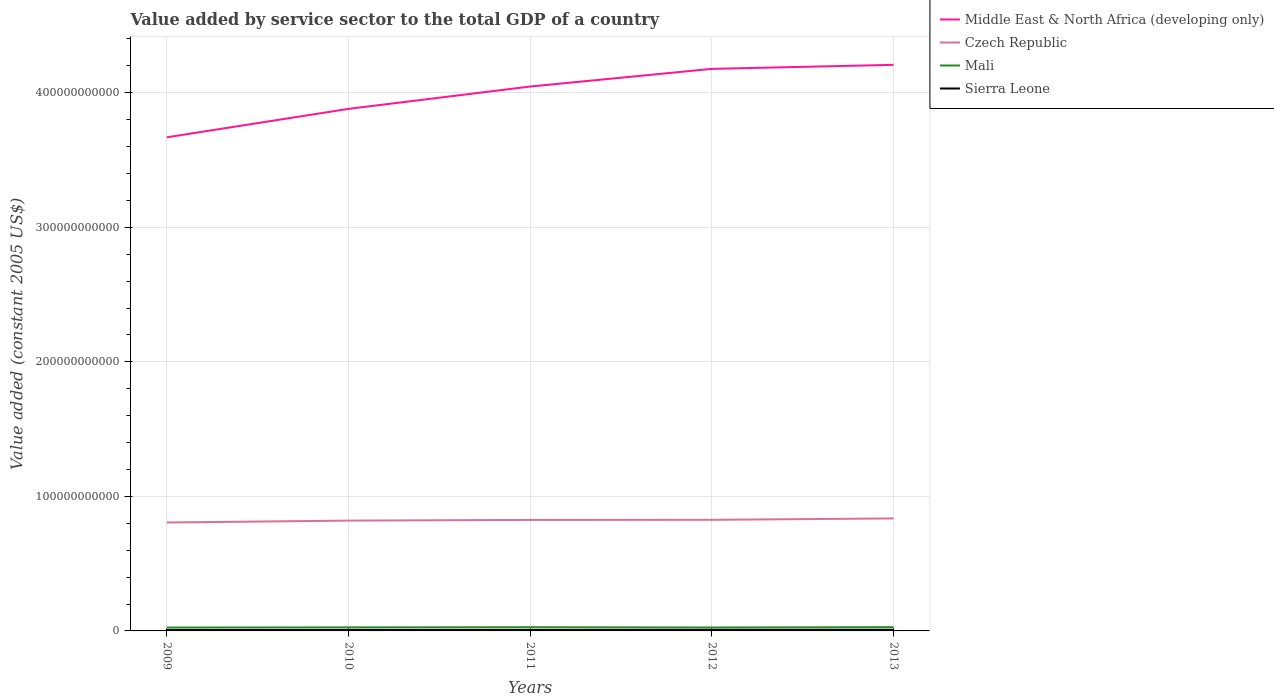How many different coloured lines are there?
Ensure brevity in your answer.  4. Does the line corresponding to Sierra Leone intersect with the line corresponding to Middle East & North Africa (developing only)?
Give a very brief answer. No. Is the number of lines equal to the number of legend labels?
Provide a succinct answer. Yes. Across all years, what is the maximum value added by service sector in Czech Republic?
Make the answer very short. 8.06e+1. In which year was the value added by service sector in Middle East & North Africa (developing only) maximum?
Give a very brief answer. 2009. What is the total value added by service sector in Sierra Leone in the graph?
Provide a short and direct response. -1.74e+07. What is the difference between the highest and the second highest value added by service sector in Czech Republic?
Your answer should be compact. 3.04e+09. Is the value added by service sector in Sierra Leone strictly greater than the value added by service sector in Czech Republic over the years?
Your answer should be compact. Yes. What is the difference between two consecutive major ticks on the Y-axis?
Offer a very short reply. 1.00e+11. Are the values on the major ticks of Y-axis written in scientific E-notation?
Make the answer very short. No. Does the graph contain any zero values?
Provide a succinct answer. No. Where does the legend appear in the graph?
Provide a succinct answer. Top right. How are the legend labels stacked?
Give a very brief answer. Vertical. What is the title of the graph?
Your response must be concise. Value added by service sector to the total GDP of a country. What is the label or title of the Y-axis?
Provide a short and direct response. Value added (constant 2005 US$). What is the Value added (constant 2005 US$) in Middle East & North Africa (developing only) in 2009?
Offer a terse response. 3.67e+11. What is the Value added (constant 2005 US$) of Czech Republic in 2009?
Keep it short and to the point. 8.06e+1. What is the Value added (constant 2005 US$) of Mali in 2009?
Offer a very short reply. 2.51e+09. What is the Value added (constant 2005 US$) of Sierra Leone in 2009?
Offer a terse response. 6.68e+08. What is the Value added (constant 2005 US$) in Middle East & North Africa (developing only) in 2010?
Keep it short and to the point. 3.88e+11. What is the Value added (constant 2005 US$) of Czech Republic in 2010?
Provide a short and direct response. 8.20e+1. What is the Value added (constant 2005 US$) of Mali in 2010?
Your answer should be very brief. 2.63e+09. What is the Value added (constant 2005 US$) of Sierra Leone in 2010?
Ensure brevity in your answer.  7.14e+08. What is the Value added (constant 2005 US$) in Middle East & North Africa (developing only) in 2011?
Provide a short and direct response. 4.05e+11. What is the Value added (constant 2005 US$) of Czech Republic in 2011?
Keep it short and to the point. 8.25e+1. What is the Value added (constant 2005 US$) in Mali in 2011?
Your answer should be compact. 2.73e+09. What is the Value added (constant 2005 US$) of Sierra Leone in 2011?
Make the answer very short. 7.31e+08. What is the Value added (constant 2005 US$) in Middle East & North Africa (developing only) in 2012?
Make the answer very short. 4.18e+11. What is the Value added (constant 2005 US$) in Czech Republic in 2012?
Provide a short and direct response. 8.26e+1. What is the Value added (constant 2005 US$) in Mali in 2012?
Offer a terse response. 2.54e+09. What is the Value added (constant 2005 US$) of Sierra Leone in 2012?
Your answer should be very brief. 7.75e+08. What is the Value added (constant 2005 US$) in Middle East & North Africa (developing only) in 2013?
Offer a terse response. 4.21e+11. What is the Value added (constant 2005 US$) in Czech Republic in 2013?
Provide a succinct answer. 8.36e+1. What is the Value added (constant 2005 US$) of Mali in 2013?
Offer a very short reply. 2.77e+09. What is the Value added (constant 2005 US$) in Sierra Leone in 2013?
Offer a terse response. 8.22e+08. Across all years, what is the maximum Value added (constant 2005 US$) in Middle East & North Africa (developing only)?
Make the answer very short. 4.21e+11. Across all years, what is the maximum Value added (constant 2005 US$) in Czech Republic?
Your answer should be very brief. 8.36e+1. Across all years, what is the maximum Value added (constant 2005 US$) of Mali?
Offer a very short reply. 2.77e+09. Across all years, what is the maximum Value added (constant 2005 US$) of Sierra Leone?
Offer a terse response. 8.22e+08. Across all years, what is the minimum Value added (constant 2005 US$) of Middle East & North Africa (developing only)?
Your response must be concise. 3.67e+11. Across all years, what is the minimum Value added (constant 2005 US$) in Czech Republic?
Your answer should be very brief. 8.06e+1. Across all years, what is the minimum Value added (constant 2005 US$) in Mali?
Provide a succinct answer. 2.51e+09. Across all years, what is the minimum Value added (constant 2005 US$) in Sierra Leone?
Your response must be concise. 6.68e+08. What is the total Value added (constant 2005 US$) in Middle East & North Africa (developing only) in the graph?
Provide a short and direct response. 2.00e+12. What is the total Value added (constant 2005 US$) in Czech Republic in the graph?
Provide a short and direct response. 4.11e+11. What is the total Value added (constant 2005 US$) in Mali in the graph?
Give a very brief answer. 1.32e+1. What is the total Value added (constant 2005 US$) of Sierra Leone in the graph?
Ensure brevity in your answer.  3.71e+09. What is the difference between the Value added (constant 2005 US$) of Middle East & North Africa (developing only) in 2009 and that in 2010?
Offer a very short reply. -2.12e+1. What is the difference between the Value added (constant 2005 US$) in Czech Republic in 2009 and that in 2010?
Your answer should be compact. -1.40e+09. What is the difference between the Value added (constant 2005 US$) of Mali in 2009 and that in 2010?
Make the answer very short. -1.14e+08. What is the difference between the Value added (constant 2005 US$) of Sierra Leone in 2009 and that in 2010?
Make the answer very short. -4.56e+07. What is the difference between the Value added (constant 2005 US$) in Middle East & North Africa (developing only) in 2009 and that in 2011?
Keep it short and to the point. -3.78e+1. What is the difference between the Value added (constant 2005 US$) in Czech Republic in 2009 and that in 2011?
Keep it short and to the point. -1.93e+09. What is the difference between the Value added (constant 2005 US$) of Mali in 2009 and that in 2011?
Make the answer very short. -2.14e+08. What is the difference between the Value added (constant 2005 US$) of Sierra Leone in 2009 and that in 2011?
Offer a very short reply. -6.30e+07. What is the difference between the Value added (constant 2005 US$) in Middle East & North Africa (developing only) in 2009 and that in 2012?
Keep it short and to the point. -5.09e+1. What is the difference between the Value added (constant 2005 US$) of Czech Republic in 2009 and that in 2012?
Your answer should be very brief. -2.00e+09. What is the difference between the Value added (constant 2005 US$) of Mali in 2009 and that in 2012?
Ensure brevity in your answer.  -3.21e+07. What is the difference between the Value added (constant 2005 US$) of Sierra Leone in 2009 and that in 2012?
Keep it short and to the point. -1.07e+08. What is the difference between the Value added (constant 2005 US$) of Middle East & North Africa (developing only) in 2009 and that in 2013?
Your answer should be compact. -5.39e+1. What is the difference between the Value added (constant 2005 US$) of Czech Republic in 2009 and that in 2013?
Make the answer very short. -3.04e+09. What is the difference between the Value added (constant 2005 US$) in Mali in 2009 and that in 2013?
Give a very brief answer. -2.59e+08. What is the difference between the Value added (constant 2005 US$) in Sierra Leone in 2009 and that in 2013?
Keep it short and to the point. -1.54e+08. What is the difference between the Value added (constant 2005 US$) of Middle East & North Africa (developing only) in 2010 and that in 2011?
Offer a terse response. -1.66e+1. What is the difference between the Value added (constant 2005 US$) of Czech Republic in 2010 and that in 2011?
Provide a short and direct response. -5.31e+08. What is the difference between the Value added (constant 2005 US$) in Mali in 2010 and that in 2011?
Your answer should be very brief. -1.00e+08. What is the difference between the Value added (constant 2005 US$) in Sierra Leone in 2010 and that in 2011?
Provide a succinct answer. -1.74e+07. What is the difference between the Value added (constant 2005 US$) in Middle East & North Africa (developing only) in 2010 and that in 2012?
Ensure brevity in your answer.  -2.97e+1. What is the difference between the Value added (constant 2005 US$) in Czech Republic in 2010 and that in 2012?
Offer a terse response. -5.99e+08. What is the difference between the Value added (constant 2005 US$) of Mali in 2010 and that in 2012?
Provide a short and direct response. 8.20e+07. What is the difference between the Value added (constant 2005 US$) of Sierra Leone in 2010 and that in 2012?
Your answer should be very brief. -6.15e+07. What is the difference between the Value added (constant 2005 US$) in Middle East & North Africa (developing only) in 2010 and that in 2013?
Provide a short and direct response. -3.27e+1. What is the difference between the Value added (constant 2005 US$) in Czech Republic in 2010 and that in 2013?
Your response must be concise. -1.63e+09. What is the difference between the Value added (constant 2005 US$) of Mali in 2010 and that in 2013?
Your response must be concise. -1.45e+08. What is the difference between the Value added (constant 2005 US$) in Sierra Leone in 2010 and that in 2013?
Ensure brevity in your answer.  -1.08e+08. What is the difference between the Value added (constant 2005 US$) in Middle East & North Africa (developing only) in 2011 and that in 2012?
Keep it short and to the point. -1.31e+1. What is the difference between the Value added (constant 2005 US$) in Czech Republic in 2011 and that in 2012?
Give a very brief answer. -6.85e+07. What is the difference between the Value added (constant 2005 US$) in Mali in 2011 and that in 2012?
Ensure brevity in your answer.  1.82e+08. What is the difference between the Value added (constant 2005 US$) in Sierra Leone in 2011 and that in 2012?
Provide a succinct answer. -4.41e+07. What is the difference between the Value added (constant 2005 US$) in Middle East & North Africa (developing only) in 2011 and that in 2013?
Offer a terse response. -1.61e+1. What is the difference between the Value added (constant 2005 US$) of Czech Republic in 2011 and that in 2013?
Your answer should be very brief. -1.10e+09. What is the difference between the Value added (constant 2005 US$) in Mali in 2011 and that in 2013?
Provide a short and direct response. -4.50e+07. What is the difference between the Value added (constant 2005 US$) of Sierra Leone in 2011 and that in 2013?
Your answer should be compact. -9.05e+07. What is the difference between the Value added (constant 2005 US$) in Middle East & North Africa (developing only) in 2012 and that in 2013?
Ensure brevity in your answer.  -2.99e+09. What is the difference between the Value added (constant 2005 US$) in Czech Republic in 2012 and that in 2013?
Make the answer very short. -1.04e+09. What is the difference between the Value added (constant 2005 US$) in Mali in 2012 and that in 2013?
Ensure brevity in your answer.  -2.27e+08. What is the difference between the Value added (constant 2005 US$) in Sierra Leone in 2012 and that in 2013?
Provide a short and direct response. -4.64e+07. What is the difference between the Value added (constant 2005 US$) of Middle East & North Africa (developing only) in 2009 and the Value added (constant 2005 US$) of Czech Republic in 2010?
Make the answer very short. 2.85e+11. What is the difference between the Value added (constant 2005 US$) of Middle East & North Africa (developing only) in 2009 and the Value added (constant 2005 US$) of Mali in 2010?
Your response must be concise. 3.64e+11. What is the difference between the Value added (constant 2005 US$) of Middle East & North Africa (developing only) in 2009 and the Value added (constant 2005 US$) of Sierra Leone in 2010?
Give a very brief answer. 3.66e+11. What is the difference between the Value added (constant 2005 US$) of Czech Republic in 2009 and the Value added (constant 2005 US$) of Mali in 2010?
Make the answer very short. 7.80e+1. What is the difference between the Value added (constant 2005 US$) of Czech Republic in 2009 and the Value added (constant 2005 US$) of Sierra Leone in 2010?
Offer a terse response. 7.99e+1. What is the difference between the Value added (constant 2005 US$) in Mali in 2009 and the Value added (constant 2005 US$) in Sierra Leone in 2010?
Your response must be concise. 1.80e+09. What is the difference between the Value added (constant 2005 US$) of Middle East & North Africa (developing only) in 2009 and the Value added (constant 2005 US$) of Czech Republic in 2011?
Keep it short and to the point. 2.84e+11. What is the difference between the Value added (constant 2005 US$) of Middle East & North Africa (developing only) in 2009 and the Value added (constant 2005 US$) of Mali in 2011?
Make the answer very short. 3.64e+11. What is the difference between the Value added (constant 2005 US$) in Middle East & North Africa (developing only) in 2009 and the Value added (constant 2005 US$) in Sierra Leone in 2011?
Give a very brief answer. 3.66e+11. What is the difference between the Value added (constant 2005 US$) in Czech Republic in 2009 and the Value added (constant 2005 US$) in Mali in 2011?
Your answer should be compact. 7.79e+1. What is the difference between the Value added (constant 2005 US$) of Czech Republic in 2009 and the Value added (constant 2005 US$) of Sierra Leone in 2011?
Your response must be concise. 7.99e+1. What is the difference between the Value added (constant 2005 US$) of Mali in 2009 and the Value added (constant 2005 US$) of Sierra Leone in 2011?
Offer a very short reply. 1.78e+09. What is the difference between the Value added (constant 2005 US$) in Middle East & North Africa (developing only) in 2009 and the Value added (constant 2005 US$) in Czech Republic in 2012?
Your answer should be very brief. 2.84e+11. What is the difference between the Value added (constant 2005 US$) of Middle East & North Africa (developing only) in 2009 and the Value added (constant 2005 US$) of Mali in 2012?
Provide a succinct answer. 3.64e+11. What is the difference between the Value added (constant 2005 US$) of Middle East & North Africa (developing only) in 2009 and the Value added (constant 2005 US$) of Sierra Leone in 2012?
Keep it short and to the point. 3.66e+11. What is the difference between the Value added (constant 2005 US$) of Czech Republic in 2009 and the Value added (constant 2005 US$) of Mali in 2012?
Provide a short and direct response. 7.80e+1. What is the difference between the Value added (constant 2005 US$) of Czech Republic in 2009 and the Value added (constant 2005 US$) of Sierra Leone in 2012?
Give a very brief answer. 7.98e+1. What is the difference between the Value added (constant 2005 US$) of Mali in 2009 and the Value added (constant 2005 US$) of Sierra Leone in 2012?
Keep it short and to the point. 1.74e+09. What is the difference between the Value added (constant 2005 US$) of Middle East & North Africa (developing only) in 2009 and the Value added (constant 2005 US$) of Czech Republic in 2013?
Provide a short and direct response. 2.83e+11. What is the difference between the Value added (constant 2005 US$) of Middle East & North Africa (developing only) in 2009 and the Value added (constant 2005 US$) of Mali in 2013?
Offer a very short reply. 3.64e+11. What is the difference between the Value added (constant 2005 US$) of Middle East & North Africa (developing only) in 2009 and the Value added (constant 2005 US$) of Sierra Leone in 2013?
Ensure brevity in your answer.  3.66e+11. What is the difference between the Value added (constant 2005 US$) of Czech Republic in 2009 and the Value added (constant 2005 US$) of Mali in 2013?
Your answer should be very brief. 7.78e+1. What is the difference between the Value added (constant 2005 US$) in Czech Republic in 2009 and the Value added (constant 2005 US$) in Sierra Leone in 2013?
Give a very brief answer. 7.98e+1. What is the difference between the Value added (constant 2005 US$) of Mali in 2009 and the Value added (constant 2005 US$) of Sierra Leone in 2013?
Give a very brief answer. 1.69e+09. What is the difference between the Value added (constant 2005 US$) in Middle East & North Africa (developing only) in 2010 and the Value added (constant 2005 US$) in Czech Republic in 2011?
Keep it short and to the point. 3.06e+11. What is the difference between the Value added (constant 2005 US$) in Middle East & North Africa (developing only) in 2010 and the Value added (constant 2005 US$) in Mali in 2011?
Your response must be concise. 3.85e+11. What is the difference between the Value added (constant 2005 US$) in Middle East & North Africa (developing only) in 2010 and the Value added (constant 2005 US$) in Sierra Leone in 2011?
Make the answer very short. 3.87e+11. What is the difference between the Value added (constant 2005 US$) of Czech Republic in 2010 and the Value added (constant 2005 US$) of Mali in 2011?
Make the answer very short. 7.93e+1. What is the difference between the Value added (constant 2005 US$) of Czech Republic in 2010 and the Value added (constant 2005 US$) of Sierra Leone in 2011?
Ensure brevity in your answer.  8.13e+1. What is the difference between the Value added (constant 2005 US$) in Mali in 2010 and the Value added (constant 2005 US$) in Sierra Leone in 2011?
Give a very brief answer. 1.89e+09. What is the difference between the Value added (constant 2005 US$) in Middle East & North Africa (developing only) in 2010 and the Value added (constant 2005 US$) in Czech Republic in 2012?
Make the answer very short. 3.05e+11. What is the difference between the Value added (constant 2005 US$) of Middle East & North Africa (developing only) in 2010 and the Value added (constant 2005 US$) of Mali in 2012?
Your answer should be very brief. 3.86e+11. What is the difference between the Value added (constant 2005 US$) in Middle East & North Africa (developing only) in 2010 and the Value added (constant 2005 US$) in Sierra Leone in 2012?
Make the answer very short. 3.87e+11. What is the difference between the Value added (constant 2005 US$) of Czech Republic in 2010 and the Value added (constant 2005 US$) of Mali in 2012?
Provide a short and direct response. 7.94e+1. What is the difference between the Value added (constant 2005 US$) in Czech Republic in 2010 and the Value added (constant 2005 US$) in Sierra Leone in 2012?
Give a very brief answer. 8.12e+1. What is the difference between the Value added (constant 2005 US$) of Mali in 2010 and the Value added (constant 2005 US$) of Sierra Leone in 2012?
Your response must be concise. 1.85e+09. What is the difference between the Value added (constant 2005 US$) in Middle East & North Africa (developing only) in 2010 and the Value added (constant 2005 US$) in Czech Republic in 2013?
Provide a succinct answer. 3.04e+11. What is the difference between the Value added (constant 2005 US$) of Middle East & North Africa (developing only) in 2010 and the Value added (constant 2005 US$) of Mali in 2013?
Your response must be concise. 3.85e+11. What is the difference between the Value added (constant 2005 US$) in Middle East & North Africa (developing only) in 2010 and the Value added (constant 2005 US$) in Sierra Leone in 2013?
Make the answer very short. 3.87e+11. What is the difference between the Value added (constant 2005 US$) in Czech Republic in 2010 and the Value added (constant 2005 US$) in Mali in 2013?
Your answer should be very brief. 7.92e+1. What is the difference between the Value added (constant 2005 US$) in Czech Republic in 2010 and the Value added (constant 2005 US$) in Sierra Leone in 2013?
Make the answer very short. 8.12e+1. What is the difference between the Value added (constant 2005 US$) in Mali in 2010 and the Value added (constant 2005 US$) in Sierra Leone in 2013?
Provide a short and direct response. 1.80e+09. What is the difference between the Value added (constant 2005 US$) of Middle East & North Africa (developing only) in 2011 and the Value added (constant 2005 US$) of Czech Republic in 2012?
Your response must be concise. 3.22e+11. What is the difference between the Value added (constant 2005 US$) in Middle East & North Africa (developing only) in 2011 and the Value added (constant 2005 US$) in Mali in 2012?
Your response must be concise. 4.02e+11. What is the difference between the Value added (constant 2005 US$) in Middle East & North Africa (developing only) in 2011 and the Value added (constant 2005 US$) in Sierra Leone in 2012?
Make the answer very short. 4.04e+11. What is the difference between the Value added (constant 2005 US$) in Czech Republic in 2011 and the Value added (constant 2005 US$) in Mali in 2012?
Offer a very short reply. 8.00e+1. What is the difference between the Value added (constant 2005 US$) in Czech Republic in 2011 and the Value added (constant 2005 US$) in Sierra Leone in 2012?
Provide a short and direct response. 8.17e+1. What is the difference between the Value added (constant 2005 US$) of Mali in 2011 and the Value added (constant 2005 US$) of Sierra Leone in 2012?
Make the answer very short. 1.95e+09. What is the difference between the Value added (constant 2005 US$) in Middle East & North Africa (developing only) in 2011 and the Value added (constant 2005 US$) in Czech Republic in 2013?
Your answer should be compact. 3.21e+11. What is the difference between the Value added (constant 2005 US$) in Middle East & North Africa (developing only) in 2011 and the Value added (constant 2005 US$) in Mali in 2013?
Provide a short and direct response. 4.02e+11. What is the difference between the Value added (constant 2005 US$) of Middle East & North Africa (developing only) in 2011 and the Value added (constant 2005 US$) of Sierra Leone in 2013?
Your answer should be compact. 4.04e+11. What is the difference between the Value added (constant 2005 US$) of Czech Republic in 2011 and the Value added (constant 2005 US$) of Mali in 2013?
Give a very brief answer. 7.97e+1. What is the difference between the Value added (constant 2005 US$) of Czech Republic in 2011 and the Value added (constant 2005 US$) of Sierra Leone in 2013?
Provide a short and direct response. 8.17e+1. What is the difference between the Value added (constant 2005 US$) in Mali in 2011 and the Value added (constant 2005 US$) in Sierra Leone in 2013?
Keep it short and to the point. 1.90e+09. What is the difference between the Value added (constant 2005 US$) of Middle East & North Africa (developing only) in 2012 and the Value added (constant 2005 US$) of Czech Republic in 2013?
Provide a short and direct response. 3.34e+11. What is the difference between the Value added (constant 2005 US$) of Middle East & North Africa (developing only) in 2012 and the Value added (constant 2005 US$) of Mali in 2013?
Your answer should be compact. 4.15e+11. What is the difference between the Value added (constant 2005 US$) of Middle East & North Africa (developing only) in 2012 and the Value added (constant 2005 US$) of Sierra Leone in 2013?
Your answer should be very brief. 4.17e+11. What is the difference between the Value added (constant 2005 US$) in Czech Republic in 2012 and the Value added (constant 2005 US$) in Mali in 2013?
Your answer should be compact. 7.98e+1. What is the difference between the Value added (constant 2005 US$) in Czech Republic in 2012 and the Value added (constant 2005 US$) in Sierra Leone in 2013?
Your answer should be compact. 8.18e+1. What is the difference between the Value added (constant 2005 US$) in Mali in 2012 and the Value added (constant 2005 US$) in Sierra Leone in 2013?
Your response must be concise. 1.72e+09. What is the average Value added (constant 2005 US$) in Middle East & North Africa (developing only) per year?
Provide a short and direct response. 4.00e+11. What is the average Value added (constant 2005 US$) of Czech Republic per year?
Keep it short and to the point. 8.23e+1. What is the average Value added (constant 2005 US$) of Mali per year?
Give a very brief answer. 2.64e+09. What is the average Value added (constant 2005 US$) in Sierra Leone per year?
Offer a terse response. 7.42e+08. In the year 2009, what is the difference between the Value added (constant 2005 US$) in Middle East & North Africa (developing only) and Value added (constant 2005 US$) in Czech Republic?
Offer a terse response. 2.86e+11. In the year 2009, what is the difference between the Value added (constant 2005 US$) in Middle East & North Africa (developing only) and Value added (constant 2005 US$) in Mali?
Offer a terse response. 3.64e+11. In the year 2009, what is the difference between the Value added (constant 2005 US$) of Middle East & North Africa (developing only) and Value added (constant 2005 US$) of Sierra Leone?
Your answer should be compact. 3.66e+11. In the year 2009, what is the difference between the Value added (constant 2005 US$) of Czech Republic and Value added (constant 2005 US$) of Mali?
Ensure brevity in your answer.  7.81e+1. In the year 2009, what is the difference between the Value added (constant 2005 US$) in Czech Republic and Value added (constant 2005 US$) in Sierra Leone?
Your answer should be very brief. 7.99e+1. In the year 2009, what is the difference between the Value added (constant 2005 US$) in Mali and Value added (constant 2005 US$) in Sierra Leone?
Keep it short and to the point. 1.84e+09. In the year 2010, what is the difference between the Value added (constant 2005 US$) of Middle East & North Africa (developing only) and Value added (constant 2005 US$) of Czech Republic?
Give a very brief answer. 3.06e+11. In the year 2010, what is the difference between the Value added (constant 2005 US$) of Middle East & North Africa (developing only) and Value added (constant 2005 US$) of Mali?
Your answer should be very brief. 3.85e+11. In the year 2010, what is the difference between the Value added (constant 2005 US$) of Middle East & North Africa (developing only) and Value added (constant 2005 US$) of Sierra Leone?
Keep it short and to the point. 3.87e+11. In the year 2010, what is the difference between the Value added (constant 2005 US$) of Czech Republic and Value added (constant 2005 US$) of Mali?
Offer a terse response. 7.94e+1. In the year 2010, what is the difference between the Value added (constant 2005 US$) in Czech Republic and Value added (constant 2005 US$) in Sierra Leone?
Your response must be concise. 8.13e+1. In the year 2010, what is the difference between the Value added (constant 2005 US$) of Mali and Value added (constant 2005 US$) of Sierra Leone?
Make the answer very short. 1.91e+09. In the year 2011, what is the difference between the Value added (constant 2005 US$) of Middle East & North Africa (developing only) and Value added (constant 2005 US$) of Czech Republic?
Make the answer very short. 3.22e+11. In the year 2011, what is the difference between the Value added (constant 2005 US$) in Middle East & North Africa (developing only) and Value added (constant 2005 US$) in Mali?
Your response must be concise. 4.02e+11. In the year 2011, what is the difference between the Value added (constant 2005 US$) of Middle East & North Africa (developing only) and Value added (constant 2005 US$) of Sierra Leone?
Offer a terse response. 4.04e+11. In the year 2011, what is the difference between the Value added (constant 2005 US$) of Czech Republic and Value added (constant 2005 US$) of Mali?
Give a very brief answer. 7.98e+1. In the year 2011, what is the difference between the Value added (constant 2005 US$) of Czech Republic and Value added (constant 2005 US$) of Sierra Leone?
Your answer should be very brief. 8.18e+1. In the year 2011, what is the difference between the Value added (constant 2005 US$) in Mali and Value added (constant 2005 US$) in Sierra Leone?
Your response must be concise. 1.99e+09. In the year 2012, what is the difference between the Value added (constant 2005 US$) in Middle East & North Africa (developing only) and Value added (constant 2005 US$) in Czech Republic?
Offer a very short reply. 3.35e+11. In the year 2012, what is the difference between the Value added (constant 2005 US$) in Middle East & North Africa (developing only) and Value added (constant 2005 US$) in Mali?
Offer a terse response. 4.15e+11. In the year 2012, what is the difference between the Value added (constant 2005 US$) of Middle East & North Africa (developing only) and Value added (constant 2005 US$) of Sierra Leone?
Keep it short and to the point. 4.17e+11. In the year 2012, what is the difference between the Value added (constant 2005 US$) in Czech Republic and Value added (constant 2005 US$) in Mali?
Offer a very short reply. 8.00e+1. In the year 2012, what is the difference between the Value added (constant 2005 US$) of Czech Republic and Value added (constant 2005 US$) of Sierra Leone?
Your answer should be very brief. 8.18e+1. In the year 2012, what is the difference between the Value added (constant 2005 US$) of Mali and Value added (constant 2005 US$) of Sierra Leone?
Your answer should be very brief. 1.77e+09. In the year 2013, what is the difference between the Value added (constant 2005 US$) in Middle East & North Africa (developing only) and Value added (constant 2005 US$) in Czech Republic?
Your answer should be compact. 3.37e+11. In the year 2013, what is the difference between the Value added (constant 2005 US$) of Middle East & North Africa (developing only) and Value added (constant 2005 US$) of Mali?
Ensure brevity in your answer.  4.18e+11. In the year 2013, what is the difference between the Value added (constant 2005 US$) of Middle East & North Africa (developing only) and Value added (constant 2005 US$) of Sierra Leone?
Ensure brevity in your answer.  4.20e+11. In the year 2013, what is the difference between the Value added (constant 2005 US$) in Czech Republic and Value added (constant 2005 US$) in Mali?
Keep it short and to the point. 8.09e+1. In the year 2013, what is the difference between the Value added (constant 2005 US$) in Czech Republic and Value added (constant 2005 US$) in Sierra Leone?
Make the answer very short. 8.28e+1. In the year 2013, what is the difference between the Value added (constant 2005 US$) of Mali and Value added (constant 2005 US$) of Sierra Leone?
Your answer should be compact. 1.95e+09. What is the ratio of the Value added (constant 2005 US$) of Middle East & North Africa (developing only) in 2009 to that in 2010?
Provide a short and direct response. 0.95. What is the ratio of the Value added (constant 2005 US$) of Czech Republic in 2009 to that in 2010?
Ensure brevity in your answer.  0.98. What is the ratio of the Value added (constant 2005 US$) of Mali in 2009 to that in 2010?
Make the answer very short. 0.96. What is the ratio of the Value added (constant 2005 US$) in Sierra Leone in 2009 to that in 2010?
Give a very brief answer. 0.94. What is the ratio of the Value added (constant 2005 US$) of Middle East & North Africa (developing only) in 2009 to that in 2011?
Provide a short and direct response. 0.91. What is the ratio of the Value added (constant 2005 US$) of Czech Republic in 2009 to that in 2011?
Your answer should be compact. 0.98. What is the ratio of the Value added (constant 2005 US$) of Mali in 2009 to that in 2011?
Keep it short and to the point. 0.92. What is the ratio of the Value added (constant 2005 US$) of Sierra Leone in 2009 to that in 2011?
Offer a terse response. 0.91. What is the ratio of the Value added (constant 2005 US$) in Middle East & North Africa (developing only) in 2009 to that in 2012?
Make the answer very short. 0.88. What is the ratio of the Value added (constant 2005 US$) of Czech Republic in 2009 to that in 2012?
Provide a short and direct response. 0.98. What is the ratio of the Value added (constant 2005 US$) in Mali in 2009 to that in 2012?
Your answer should be compact. 0.99. What is the ratio of the Value added (constant 2005 US$) in Sierra Leone in 2009 to that in 2012?
Offer a terse response. 0.86. What is the ratio of the Value added (constant 2005 US$) of Middle East & North Africa (developing only) in 2009 to that in 2013?
Provide a succinct answer. 0.87. What is the ratio of the Value added (constant 2005 US$) in Czech Republic in 2009 to that in 2013?
Offer a very short reply. 0.96. What is the ratio of the Value added (constant 2005 US$) of Mali in 2009 to that in 2013?
Your answer should be compact. 0.91. What is the ratio of the Value added (constant 2005 US$) of Sierra Leone in 2009 to that in 2013?
Your answer should be compact. 0.81. What is the ratio of the Value added (constant 2005 US$) in Middle East & North Africa (developing only) in 2010 to that in 2011?
Your response must be concise. 0.96. What is the ratio of the Value added (constant 2005 US$) of Czech Republic in 2010 to that in 2011?
Provide a short and direct response. 0.99. What is the ratio of the Value added (constant 2005 US$) in Mali in 2010 to that in 2011?
Provide a succinct answer. 0.96. What is the ratio of the Value added (constant 2005 US$) in Sierra Leone in 2010 to that in 2011?
Offer a terse response. 0.98. What is the ratio of the Value added (constant 2005 US$) of Middle East & North Africa (developing only) in 2010 to that in 2012?
Offer a terse response. 0.93. What is the ratio of the Value added (constant 2005 US$) of Czech Republic in 2010 to that in 2012?
Provide a short and direct response. 0.99. What is the ratio of the Value added (constant 2005 US$) of Mali in 2010 to that in 2012?
Your response must be concise. 1.03. What is the ratio of the Value added (constant 2005 US$) of Sierra Leone in 2010 to that in 2012?
Your answer should be very brief. 0.92. What is the ratio of the Value added (constant 2005 US$) in Middle East & North Africa (developing only) in 2010 to that in 2013?
Ensure brevity in your answer.  0.92. What is the ratio of the Value added (constant 2005 US$) of Czech Republic in 2010 to that in 2013?
Provide a short and direct response. 0.98. What is the ratio of the Value added (constant 2005 US$) in Mali in 2010 to that in 2013?
Your response must be concise. 0.95. What is the ratio of the Value added (constant 2005 US$) of Sierra Leone in 2010 to that in 2013?
Make the answer very short. 0.87. What is the ratio of the Value added (constant 2005 US$) in Middle East & North Africa (developing only) in 2011 to that in 2012?
Keep it short and to the point. 0.97. What is the ratio of the Value added (constant 2005 US$) in Czech Republic in 2011 to that in 2012?
Keep it short and to the point. 1. What is the ratio of the Value added (constant 2005 US$) of Mali in 2011 to that in 2012?
Ensure brevity in your answer.  1.07. What is the ratio of the Value added (constant 2005 US$) of Sierra Leone in 2011 to that in 2012?
Your answer should be compact. 0.94. What is the ratio of the Value added (constant 2005 US$) in Middle East & North Africa (developing only) in 2011 to that in 2013?
Keep it short and to the point. 0.96. What is the ratio of the Value added (constant 2005 US$) in Mali in 2011 to that in 2013?
Offer a terse response. 0.98. What is the ratio of the Value added (constant 2005 US$) in Sierra Leone in 2011 to that in 2013?
Your answer should be very brief. 0.89. What is the ratio of the Value added (constant 2005 US$) of Czech Republic in 2012 to that in 2013?
Provide a short and direct response. 0.99. What is the ratio of the Value added (constant 2005 US$) in Mali in 2012 to that in 2013?
Provide a short and direct response. 0.92. What is the ratio of the Value added (constant 2005 US$) in Sierra Leone in 2012 to that in 2013?
Ensure brevity in your answer.  0.94. What is the difference between the highest and the second highest Value added (constant 2005 US$) in Middle East & North Africa (developing only)?
Your answer should be very brief. 2.99e+09. What is the difference between the highest and the second highest Value added (constant 2005 US$) in Czech Republic?
Provide a succinct answer. 1.04e+09. What is the difference between the highest and the second highest Value added (constant 2005 US$) of Mali?
Ensure brevity in your answer.  4.50e+07. What is the difference between the highest and the second highest Value added (constant 2005 US$) of Sierra Leone?
Your response must be concise. 4.64e+07. What is the difference between the highest and the lowest Value added (constant 2005 US$) of Middle East & North Africa (developing only)?
Keep it short and to the point. 5.39e+1. What is the difference between the highest and the lowest Value added (constant 2005 US$) of Czech Republic?
Offer a terse response. 3.04e+09. What is the difference between the highest and the lowest Value added (constant 2005 US$) of Mali?
Ensure brevity in your answer.  2.59e+08. What is the difference between the highest and the lowest Value added (constant 2005 US$) in Sierra Leone?
Your response must be concise. 1.54e+08. 